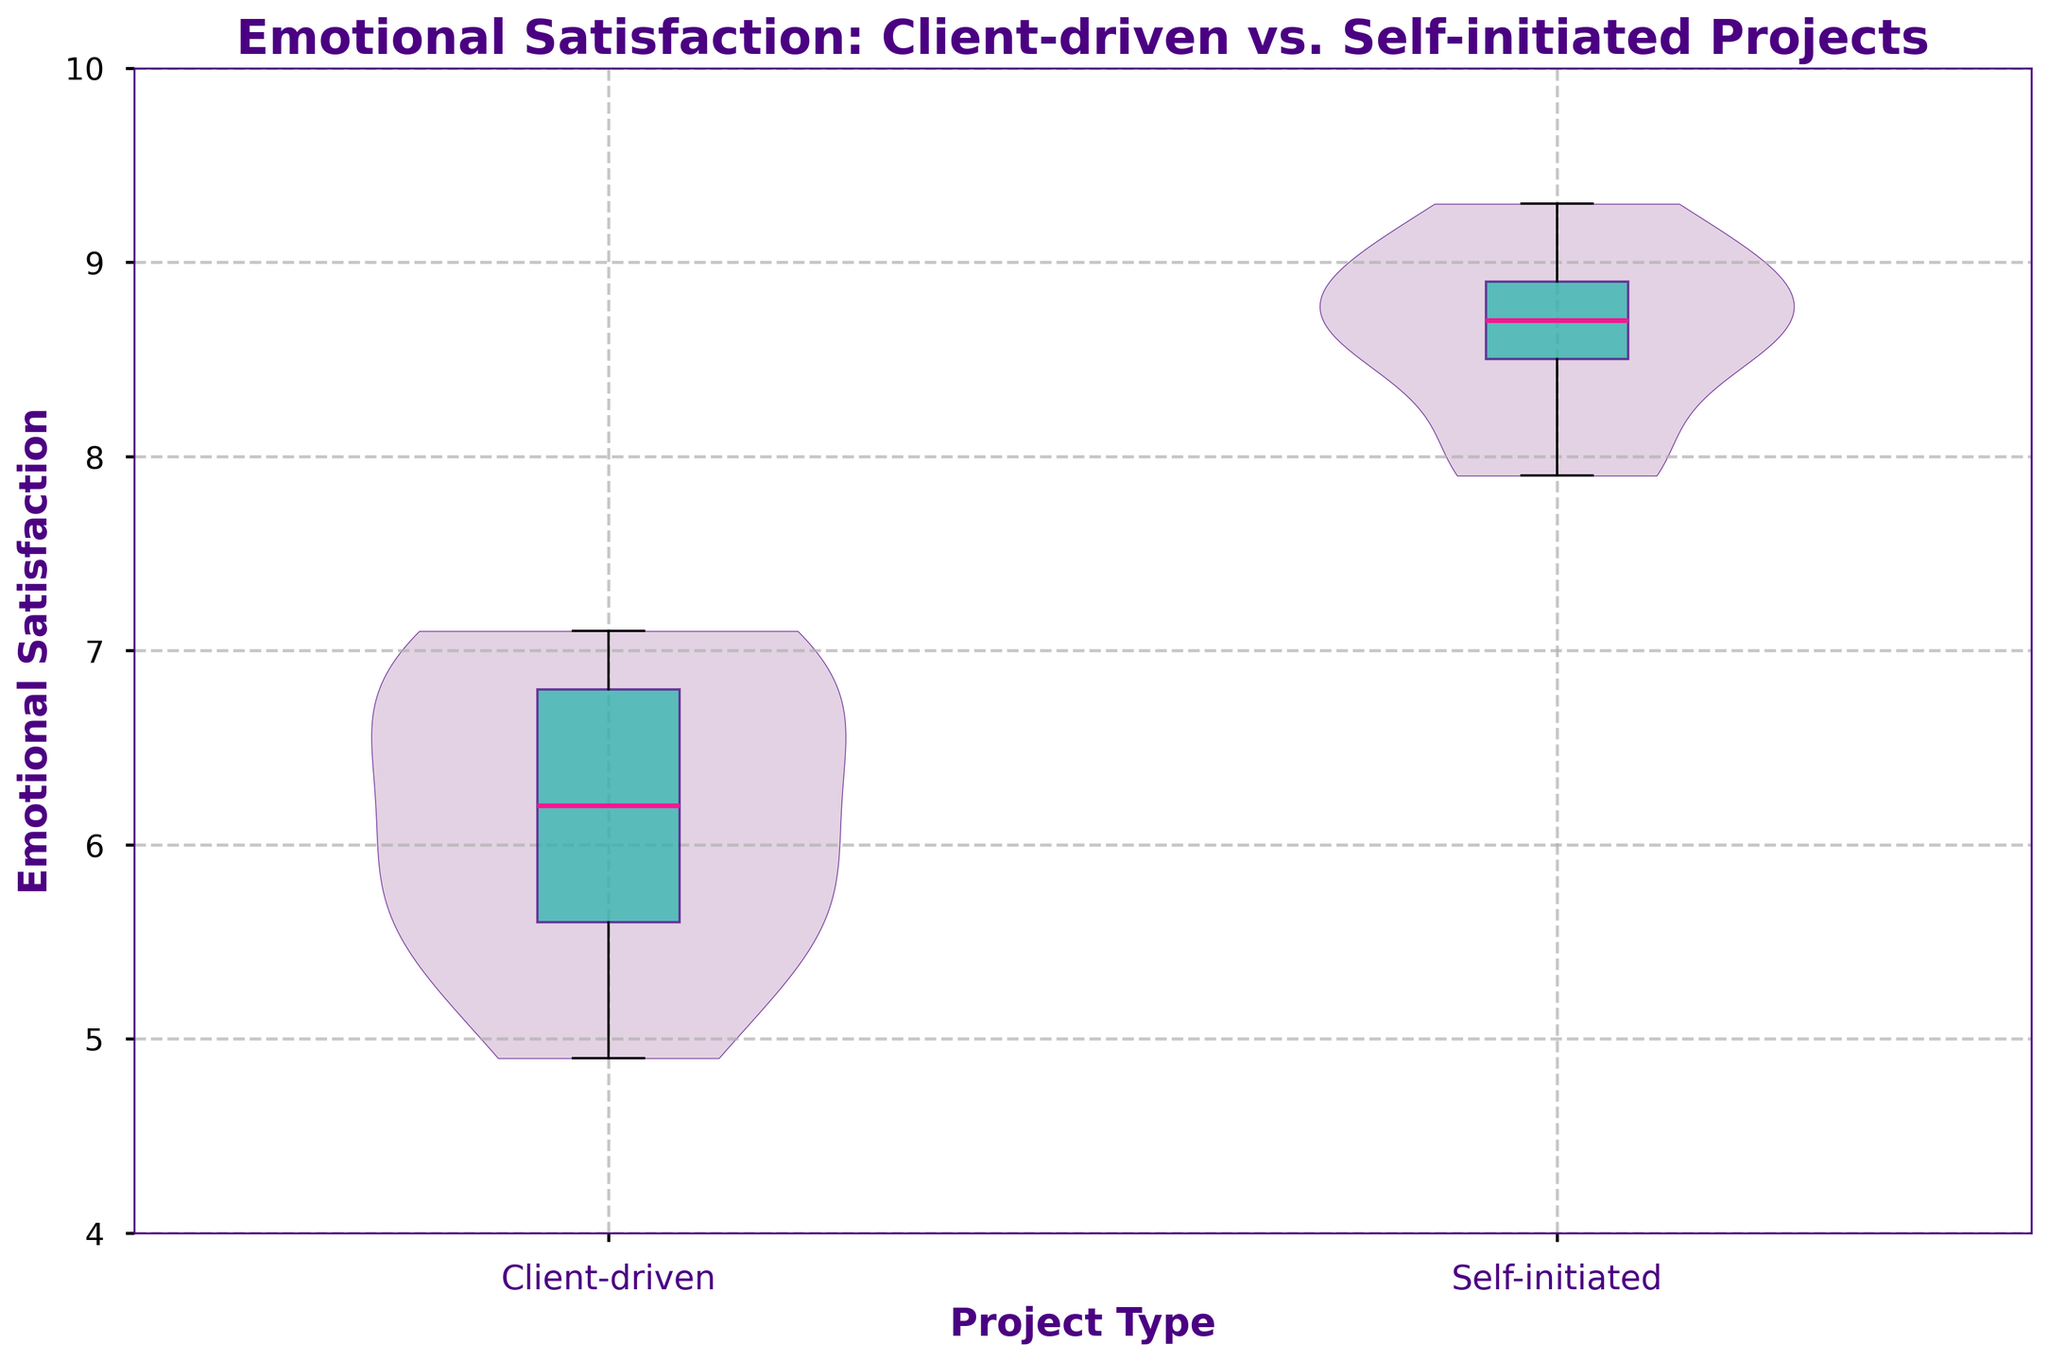What is the title of the plot? The title is located at the top of the plot and is clearly labeled. It provides an overview of what the plot represents.
Answer: Emotional Satisfaction: Client-driven vs. Self-initiated Projects Which project type has a higher median emotional satisfaction? The box plot overlay on each violin plot shows a thick line which represents the median. By comparing these lines, we can identify which median is higher. The line for self-initiated projects is higher than for client-driven projects.
Answer: Self-initiated What are the ranges of emotional satisfaction for client-driven projects? The range of a violin plot can be observed by looking at the spread of the data points from the minimum to the maximum. For client-driven projects, this range spans from the lowest to the highest point on the violin.
Answer: 4.9 to 7.1 How does the spread of self-initiated projects compare to client-driven projects? Looking at the width and spread of the two violin plots, we can see the distribution and range of values for each type. Self-initiated projects have a wider and more consistent spread towards higher values compared to client-driven projects.
Answer: Wider for self-initiated What is the color and alpha of the violin plots? The color and transparency (alpha) of the violin plots can be deduced from their visual appearance. The plots are light purple with a slight transparency, allowing us to see the grid lines through them.
Answer: Light purple with transparency How does the distribution of emotional satisfaction differ between the two project types? The distribution is shown by the shape of the violin plots. For client-driven projects, the distribution is more densely packed towards the bottom half, while self-initiated projects show a more even distribution with a higher concentration towards the top.
Answer: More dense at lower values for client-driven, more even and higher concentration for self-initiated What does the box plot overlay indicate in this figure? The box plot overlay shows the median, quartiles, and overall spread of the data within each group. It helps in understanding the central tendency and variability in a compact form on top of the violin plot.
Answer: Median, quartiles, and spread Are there any outliers shown in the plot? The box plot in this figure does not display any individual points for outliers, which means either there are no outliers or they are not shown in this specific representation.
Answer: None shown Which project type shows higher variability in emotional satisfaction? The variability in emotional satisfaction can be inferred by observing the spread and width of the violin plots. Comparing the two, self-initiated projects show a broader spread at higher satisfaction levels, indicating more variability.
Answer: Self-initiated 